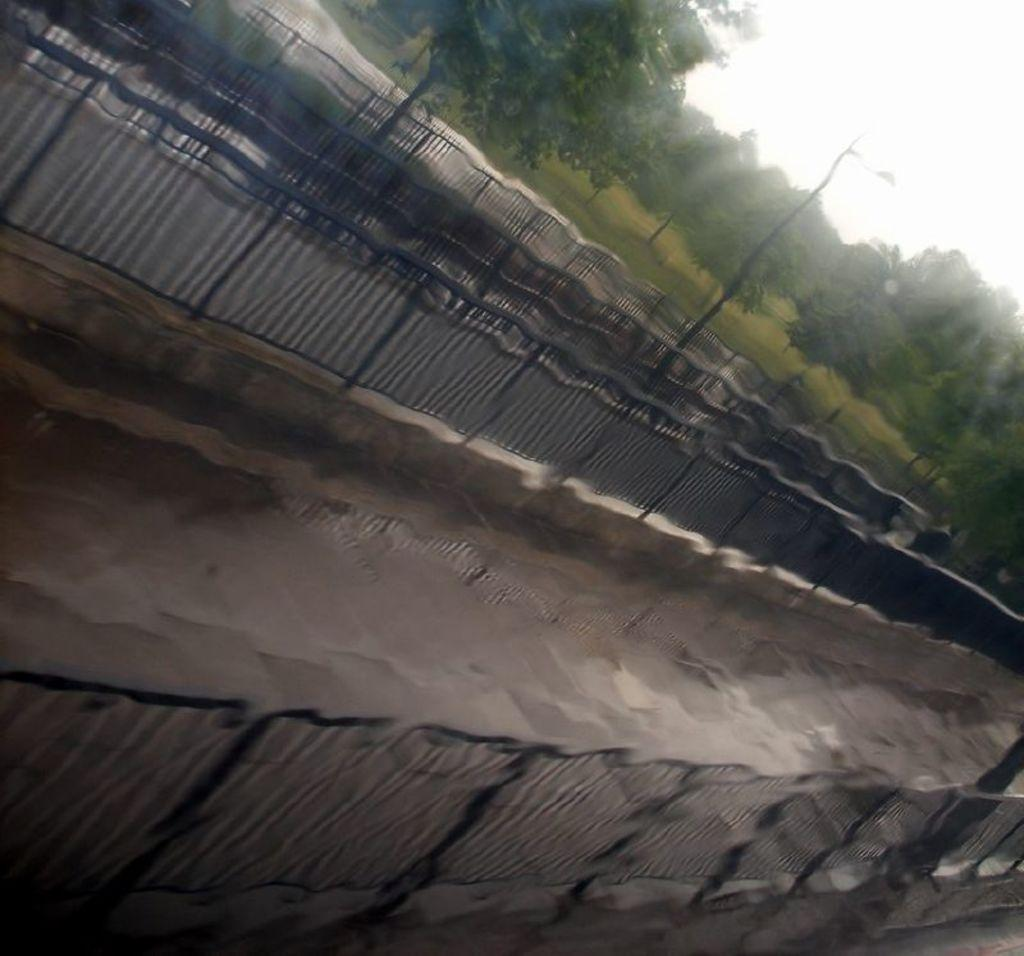What can be seen in the foreground of the image? There is a path in the image. What is located on the other side of the path? There are railings on the other side of the path. What type of vegetation is visible in the background? There are plants and trees in the background. What part of the natural environment is visible in the background? The grass surface and trees are visible in the background. What is visible in the sky in the background? The sky is visible in the background. What type of error can be seen in the image? There is no error present in the image. What type of work is the maid doing in the image? There is no maid present in the image. 